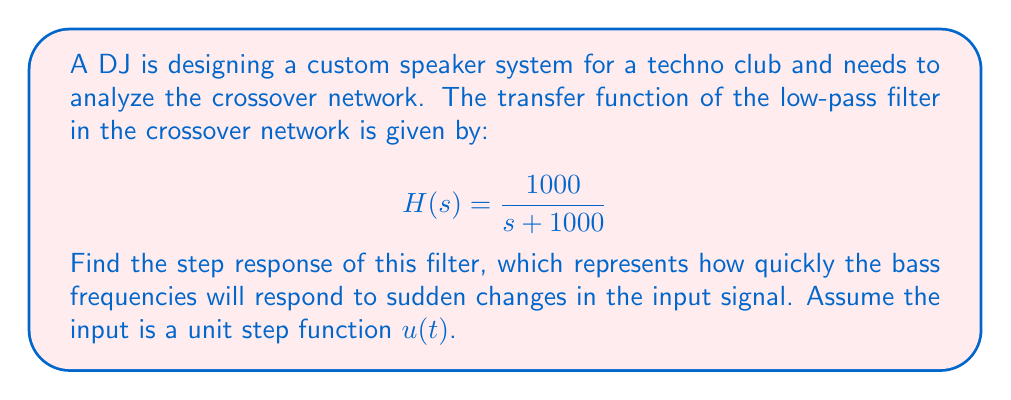Could you help me with this problem? To find the step response, we'll follow these steps:

1) The Laplace transform of the unit step function $u(t)$ is $\frac{1}{s}$.

2) The output $Y(s)$ in the s-domain is the product of the input and the transfer function:

   $$Y(s) = H(s) \cdot \frac{1}{s} = \frac{1000}{s(s + 1000)}$$

3) We can use partial fraction decomposition to split this into simpler terms:

   $$\frac{1000}{s(s + 1000)} = \frac{A}{s} + \frac{B}{s + 1000}$$

4) Solving for A and B:
   
   $A = 1$ and $B = -1$

   So, $$Y(s) = \frac{1}{s} - \frac{1}{s + 1000}$$

5) Now we can use the inverse Laplace transform to get the time-domain response:

   $$y(t) = \mathcal{L}^{-1}\{Y(s)\} = \mathcal{L}^{-1}\{\frac{1}{s}\} - \mathcal{L}^{-1}\{\frac{1}{s + 1000}\}$$

6) Using Laplace transform tables:

   $$y(t) = 1 - e^{-1000t}$$

This is the step response of the low-pass filter in the time domain.
Answer: $$y(t) = 1 - e^{-1000t}$$ 